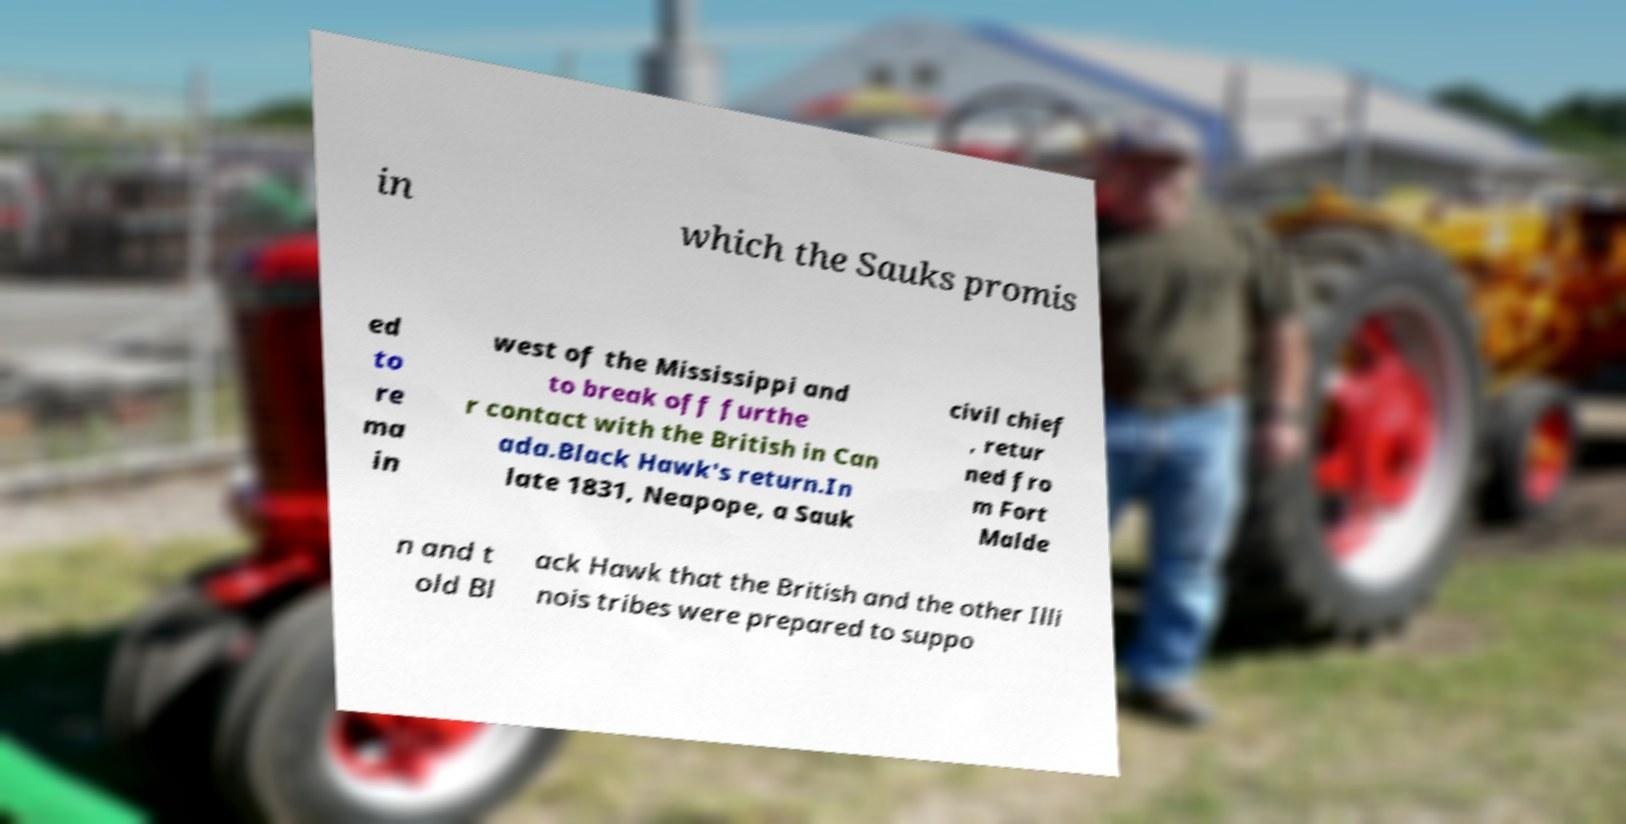Can you accurately transcribe the text from the provided image for me? in which the Sauks promis ed to re ma in west of the Mississippi and to break off furthe r contact with the British in Can ada.Black Hawk's return.In late 1831, Neapope, a Sauk civil chief , retur ned fro m Fort Malde n and t old Bl ack Hawk that the British and the other Illi nois tribes were prepared to suppo 